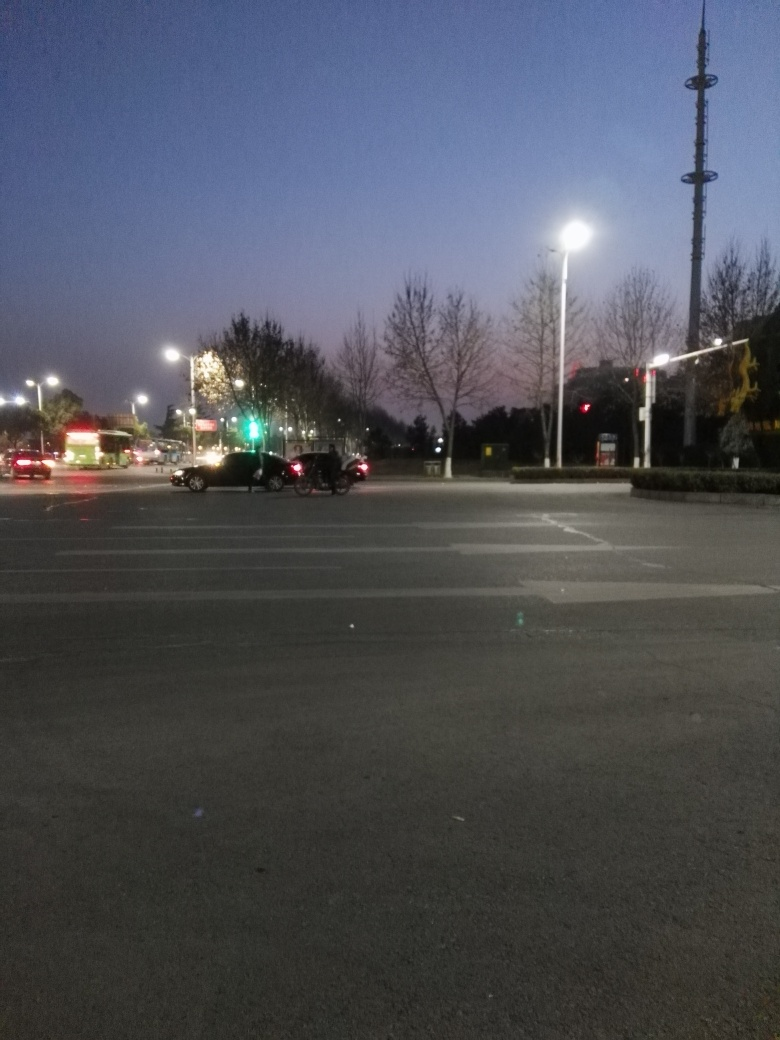What details can you tell about the location from the photo? The image depicts a modern urban environment, likely on the outskirts of a city given the openness of the space and minimal pedestrian activity. The presence of road signage and traffic lights suggests a well-organized traffic system, perhaps in a residential or commercial district. Are there any distinctive features in the image that could provide more context? A notable feature is the tall structure in the background, which resembles a telecommunications tower. It's an indication of contemporary infrastructure. Also, the style of the streetlights and the design of the road markings can provide hints about the regional location. 